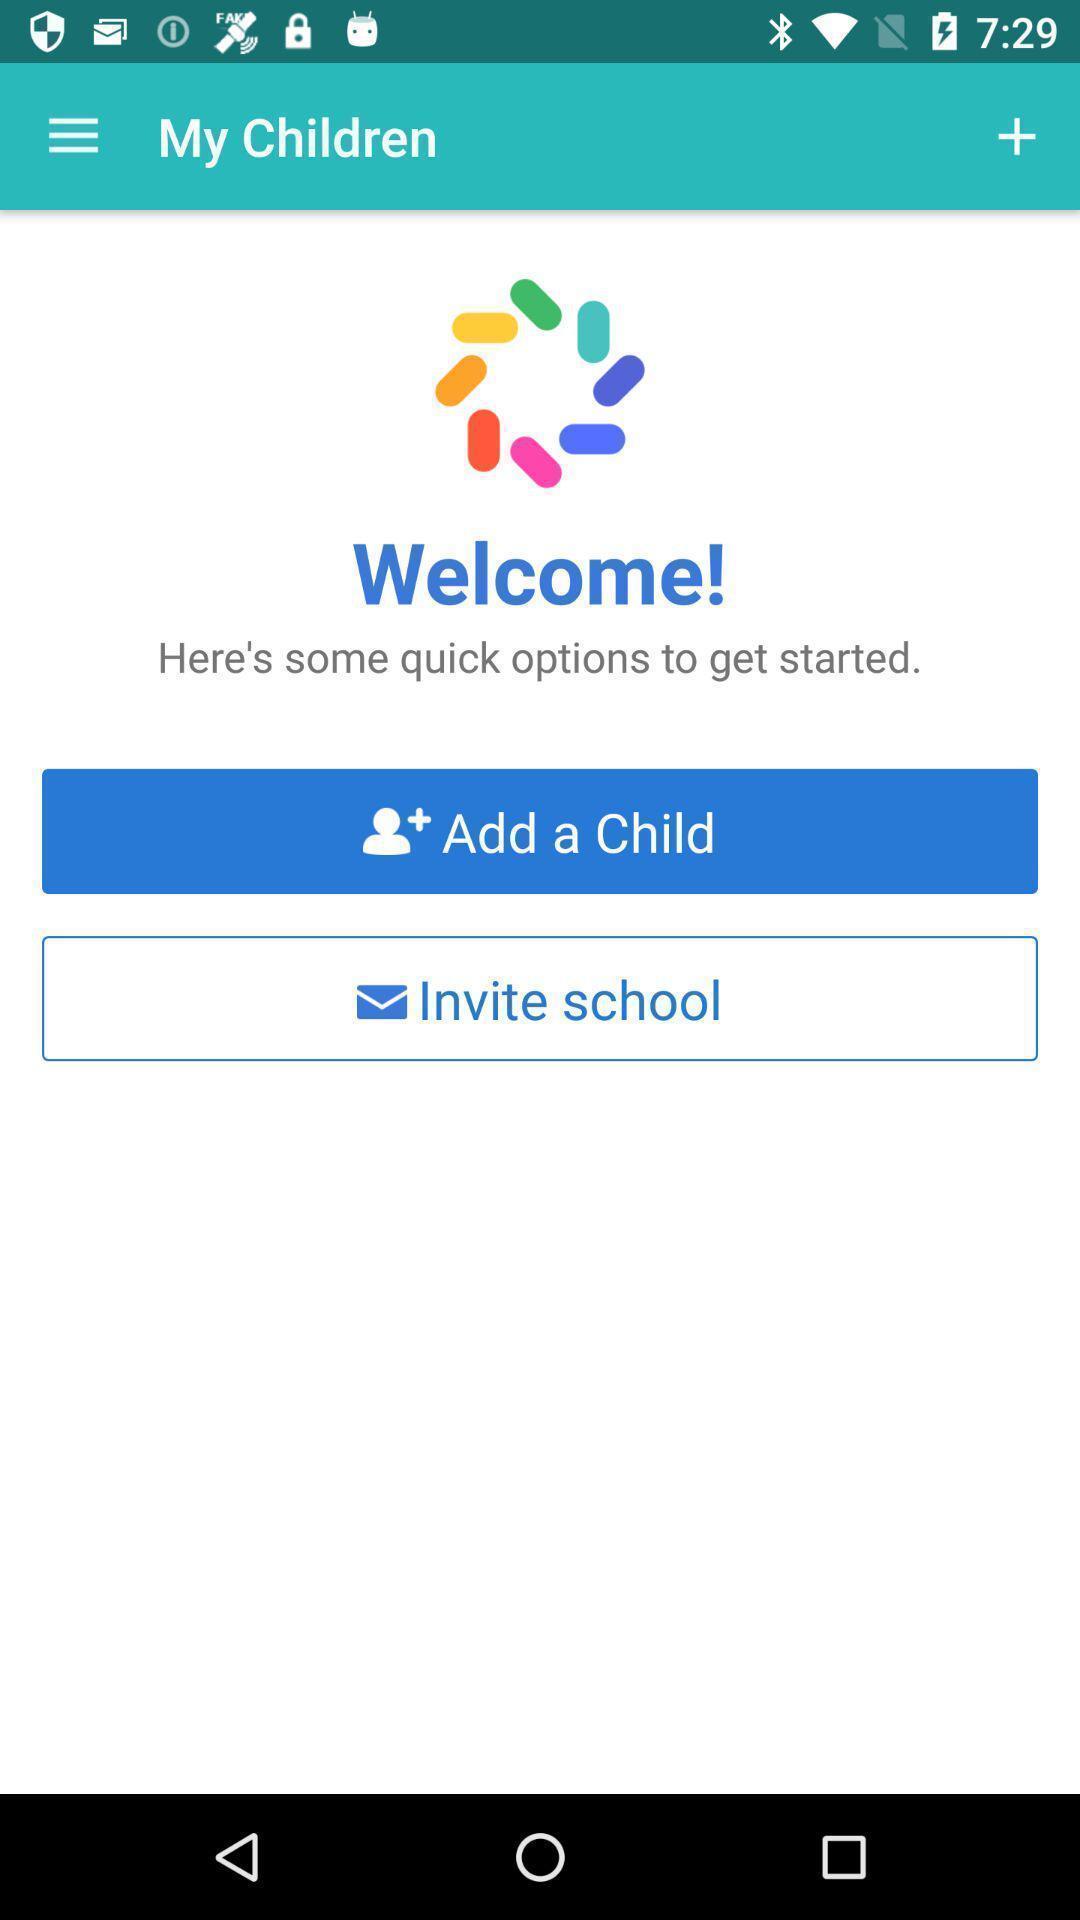What can you discern from this picture? Welcome screen. 